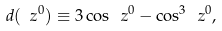<formula> <loc_0><loc_0><loc_500><loc_500>d ( \ z ^ { 0 } ) \equiv 3 \cos \ z ^ { 0 } - \cos ^ { 3 } \ z ^ { 0 } ,</formula> 